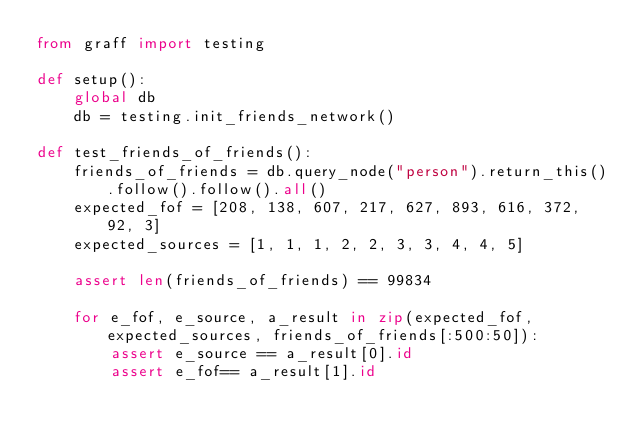<code> <loc_0><loc_0><loc_500><loc_500><_Python_>from graff import testing

def setup():
    global db
    db = testing.init_friends_network()

def test_friends_of_friends():
    friends_of_friends = db.query_node("person").return_this().follow().follow().all()
    expected_fof = [208, 138, 607, 217, 627, 893, 616, 372, 92, 3]
    expected_sources = [1, 1, 1, 2, 2, 3, 3, 4, 4, 5]

    assert len(friends_of_friends) == 99834

    for e_fof, e_source, a_result in zip(expected_fof, expected_sources, friends_of_friends[:500:50]):
        assert e_source == a_result[0].id
        assert e_fof== a_result[1].id


</code> 